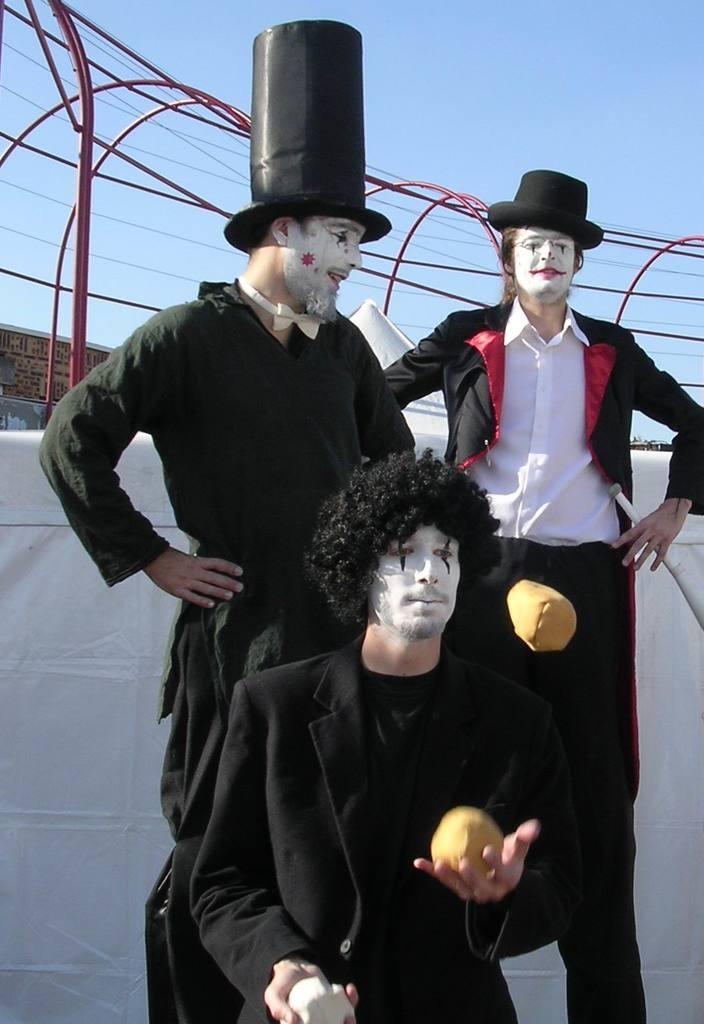How many people are in the image? There are two persons standing in the image. What is one of the persons doing in the image? There is a person standing and holding objects in the image. What can be seen at the back of the image? There is a railing at the back in the image. What is visible at the top of the image? The sky is visible at the top of the image. How many tigers can be seen in the image? There are no tigers present in the image. What is the arm of the person holding in the image? The provided facts do not mention the arm of the person holding objects, so we cannot determine its characteristics from the image. 